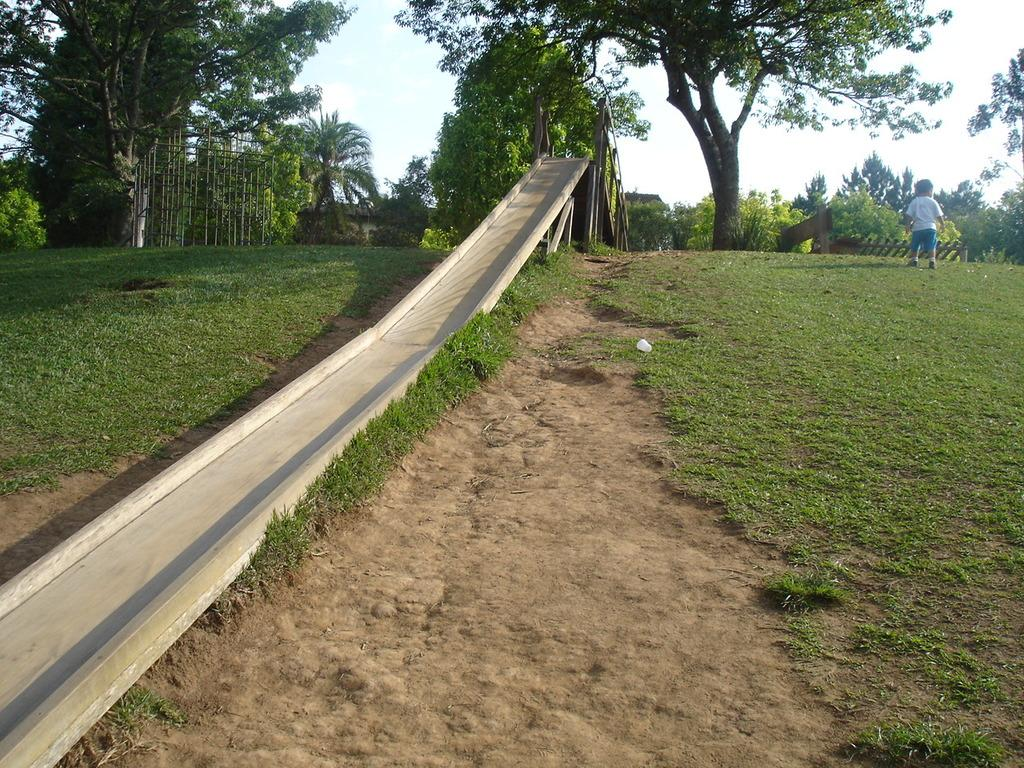What is the main subject of the image? There is a child in the image. Where is the child located? The child is on the grass. What playground equipment can be seen in the image? There is a slide in the image. What type of vegetation is present in the image? There are trees in the image. What material are some of the objects made of in the image? There are wooden objects in the image. What can be seen in the background of the image? The sky is visible in the background of the image. What type of education is the child receiving in the image? There is no indication of the child receiving any education in the image. What type of lettuce can be seen growing near the slide in the image? There is no lettuce present in the image. 